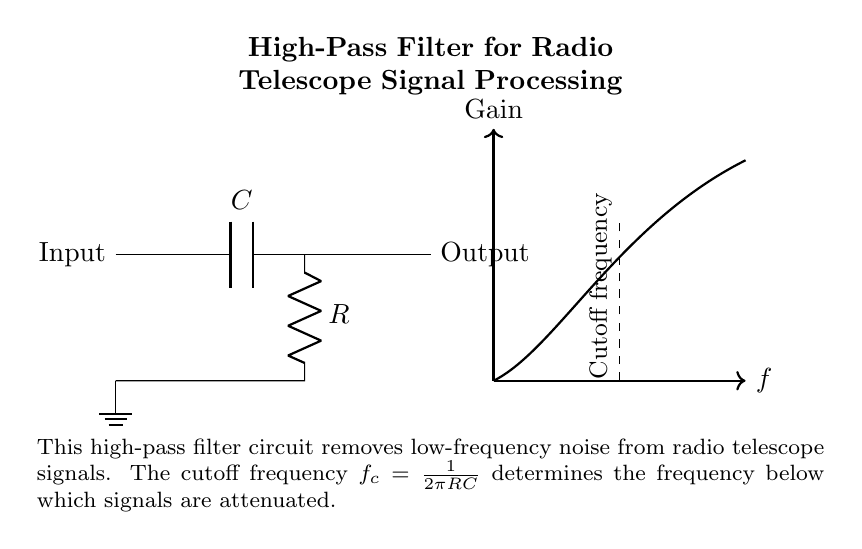What type of filter is this circuit? The circuit is a high-pass filter, as indicated by the positioning of the capacitor and resistor. In a high-pass filter, signals above a certain frequency (cutoff frequency) are allowed to pass, while lower frequencies are attenuated.
Answer: High-pass filter What is the role of the capacitor in this circuit? The capacitor blocks low-frequency signals from passing through to the output and allows higher frequency signals to pass. This behavior is characteristic of the high-pass filter configuration, where the capacitor presents low impedance to high frequencies and high impedance to low frequencies.
Answer: Blocks low frequency What is the value of the cutoff frequency? The cutoff frequency is given by the formula f_c = 1/(2πRC). This is derived from the relationship of the RC components in the high-pass filter. The specific values of R (resistor) and C (capacitor) would need to be provided to calculate a numerical cutoff frequency.
Answer: 1/(2πRC) Which component is connected in series with the capacitor? The resistor is connected in series with the capacitor in the circuit. In a high-pass filter configuration, the capacitor and resistor are arranged in series to create a frequency-dependent voltage divider.
Answer: Resistor Where does the output signal come from in this circuit? The output signal is taken across the resistor, which is the point where the filtered signal is accessed. In high-pass filter designs, this configuration allows for the desired high-frequency signals to be available at the output while attenuating the low frequencies.
Answer: Across the resistor 